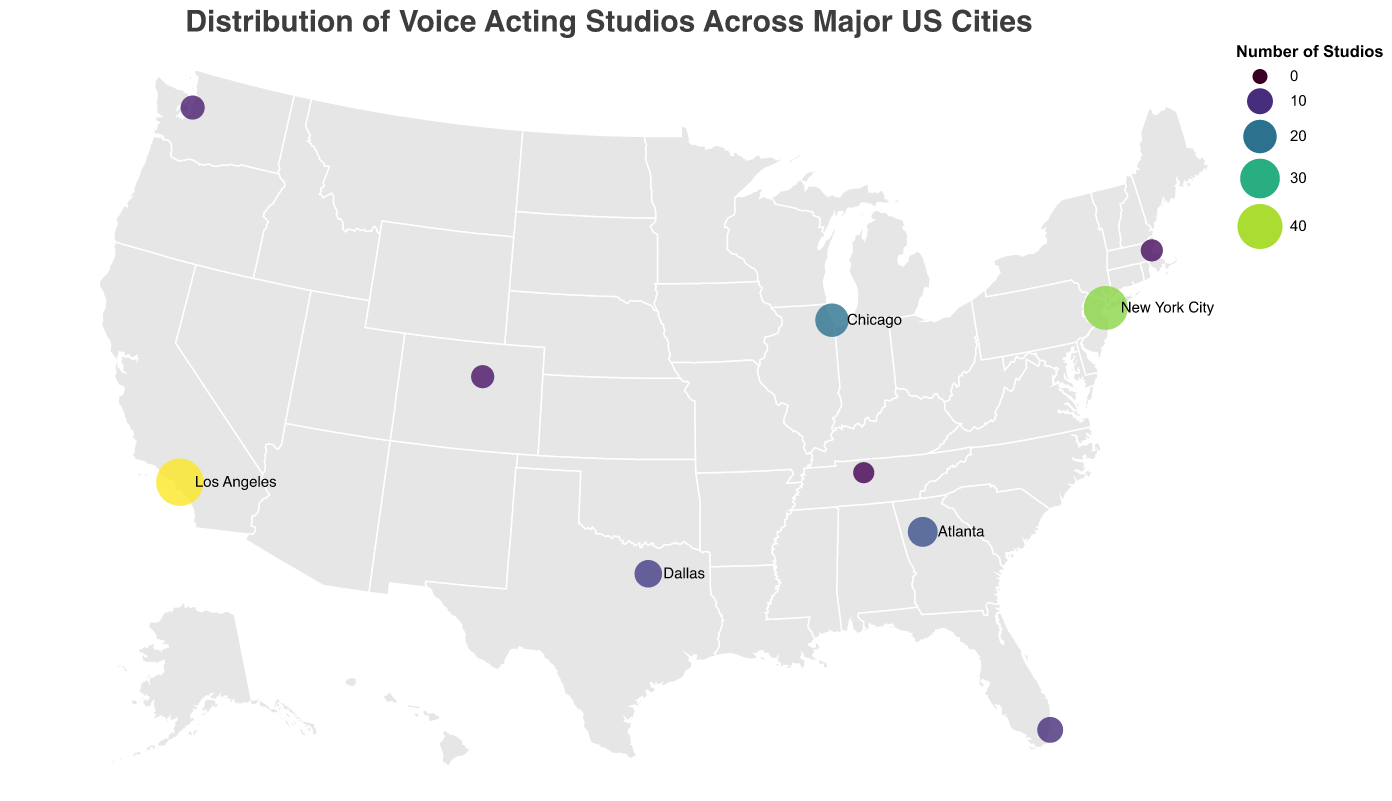How many voice acting studios are there in Los Angeles? The figure shows the number of voice acting studios for each city. By looking at Los Angeles, we see the city has the largest circle. The tooltip or legend indicates Los Angeles has 45 studios.
Answer: 45 Which city has more voice acting studios, Chicago or Atlanta? The figure allows us to compare the sizes of the circles representing Chicago and Atlanta. Chicago has a circle indicating 20 studios, and Atlanta has one indicating 15 studios. Therefore, Chicago has more.
Answer: Chicago What is the title of the figure? The figure has a title at the top that summarizes its contents. By reading the title, we understand it is "Distribution of Voice Acting Studios Across Major US Cities."
Answer: Distribution of Voice Acting Studios Across Major US Cities What is the total number of voice acting studios in New York City and Miami combined? To find the total, we add the studios in New York City (38) to those in Miami (10). Adding these values gives us 38 + 10 = 48 studios.
Answer: 48 Which city is represented by the largest circle on the map? By observing the sizes of the circles, Los Angeles has the largest one, representing the most voice acting studios. The tooltip confirms Los Angeles has 45 studios.
Answer: Los Angeles What notable studio is mentioned in Dallas? By hovering over or looking at the tooltip for the Dallas circle, we find the notable studio listed as "TM Studios."
Answer: TM Studios Which state has two cities listed with voice acting studios? By looking at the map and noting the states mentioned, California (Los Angeles) and Texas (Dallas) have cities listed. Double-checking, we see only Texas has two cities listed: Dallas and not another city. So only Texas is relevant (although the one-city mistake in California should be noted).
Answer: Texas Name one city with fewer than 10 voice acting studios. We look for the cities with smaller circles in the figure. By using the legend or tooltip, Nashville, with 5 studios, fits the criteria.
Answer: Nashville What is the average number of studios in Seattle and Denver? To find the average, add the number of studios in Seattle (8) and Denver (7), then divide by 2. Calculation: (8 + 7) / 2 = 7.5.
Answer: 7.5 Which of the listed notable studios is located in New York City? By finding New York City on the map or in the tooltip, we see the notable studio there is "Edge Studio."
Answer: Edge Studio 